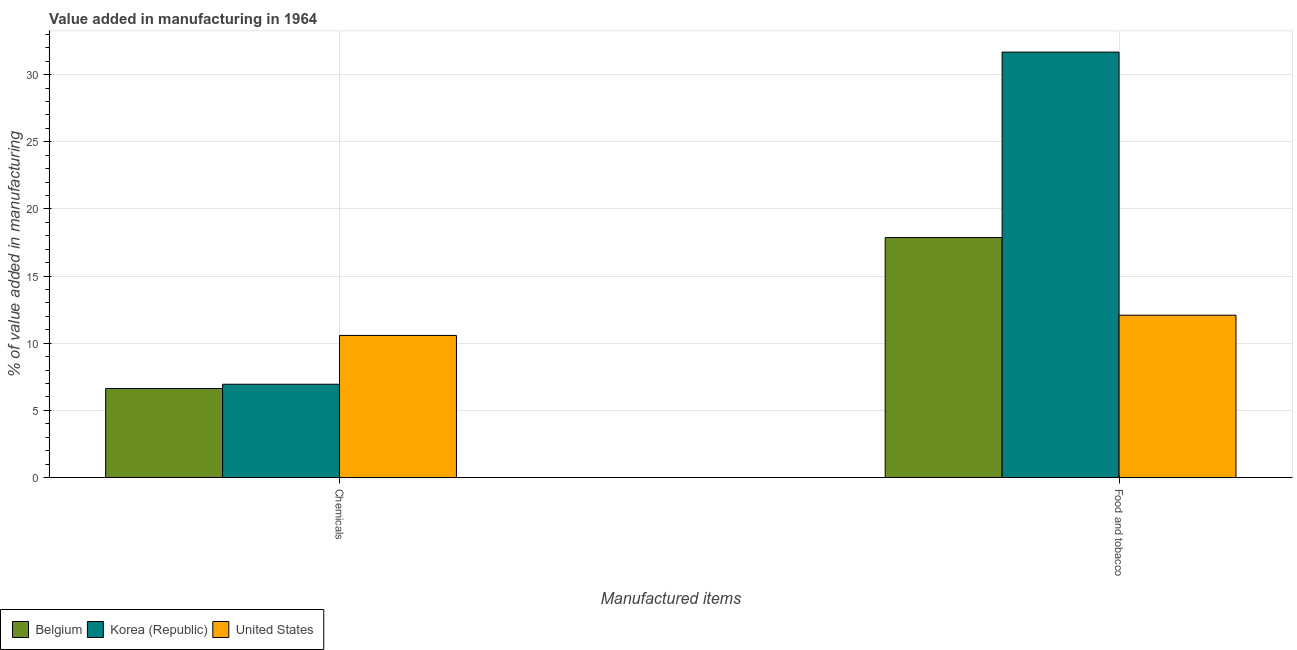How many different coloured bars are there?
Your answer should be compact. 3. Are the number of bars per tick equal to the number of legend labels?
Your answer should be very brief. Yes. How many bars are there on the 1st tick from the right?
Offer a very short reply. 3. What is the label of the 1st group of bars from the left?
Keep it short and to the point. Chemicals. What is the value added by  manufacturing chemicals in Korea (Republic)?
Your response must be concise. 6.95. Across all countries, what is the maximum value added by manufacturing food and tobacco?
Provide a short and direct response. 31.68. Across all countries, what is the minimum value added by  manufacturing chemicals?
Provide a succinct answer. 6.63. In which country was the value added by manufacturing food and tobacco maximum?
Your answer should be very brief. Korea (Republic). What is the total value added by  manufacturing chemicals in the graph?
Offer a very short reply. 24.16. What is the difference between the value added by manufacturing food and tobacco in Korea (Republic) and that in United States?
Your answer should be compact. 19.59. What is the difference between the value added by  manufacturing chemicals in Korea (Republic) and the value added by manufacturing food and tobacco in United States?
Keep it short and to the point. -5.14. What is the average value added by manufacturing food and tobacco per country?
Make the answer very short. 20.55. What is the difference between the value added by  manufacturing chemicals and value added by manufacturing food and tobacco in Korea (Republic)?
Keep it short and to the point. -24.73. In how many countries, is the value added by  manufacturing chemicals greater than 32 %?
Your answer should be very brief. 0. What is the ratio of the value added by manufacturing food and tobacco in Korea (Republic) to that in Belgium?
Make the answer very short. 1.77. Is the value added by manufacturing food and tobacco in United States less than that in Korea (Republic)?
Your response must be concise. Yes. In how many countries, is the value added by manufacturing food and tobacco greater than the average value added by manufacturing food and tobacco taken over all countries?
Make the answer very short. 1. What does the 2nd bar from the left in Food and tobacco represents?
Offer a very short reply. Korea (Republic). How many bars are there?
Provide a succinct answer. 6. Does the graph contain any zero values?
Your response must be concise. No. Does the graph contain grids?
Make the answer very short. Yes. Where does the legend appear in the graph?
Your answer should be compact. Bottom left. How are the legend labels stacked?
Your response must be concise. Horizontal. What is the title of the graph?
Keep it short and to the point. Value added in manufacturing in 1964. Does "Egypt, Arab Rep." appear as one of the legend labels in the graph?
Your answer should be compact. No. What is the label or title of the X-axis?
Your answer should be very brief. Manufactured items. What is the label or title of the Y-axis?
Offer a very short reply. % of value added in manufacturing. What is the % of value added in manufacturing in Belgium in Chemicals?
Your answer should be very brief. 6.63. What is the % of value added in manufacturing of Korea (Republic) in Chemicals?
Provide a short and direct response. 6.95. What is the % of value added in manufacturing in United States in Chemicals?
Ensure brevity in your answer.  10.58. What is the % of value added in manufacturing in Belgium in Food and tobacco?
Your response must be concise. 17.87. What is the % of value added in manufacturing of Korea (Republic) in Food and tobacco?
Make the answer very short. 31.68. What is the % of value added in manufacturing in United States in Food and tobacco?
Make the answer very short. 12.09. Across all Manufactured items, what is the maximum % of value added in manufacturing in Belgium?
Your answer should be compact. 17.87. Across all Manufactured items, what is the maximum % of value added in manufacturing of Korea (Republic)?
Make the answer very short. 31.68. Across all Manufactured items, what is the maximum % of value added in manufacturing in United States?
Keep it short and to the point. 12.09. Across all Manufactured items, what is the minimum % of value added in manufacturing of Belgium?
Ensure brevity in your answer.  6.63. Across all Manufactured items, what is the minimum % of value added in manufacturing in Korea (Republic)?
Offer a very short reply. 6.95. Across all Manufactured items, what is the minimum % of value added in manufacturing of United States?
Keep it short and to the point. 10.58. What is the total % of value added in manufacturing in Belgium in the graph?
Provide a succinct answer. 24.5. What is the total % of value added in manufacturing in Korea (Republic) in the graph?
Your answer should be compact. 38.63. What is the total % of value added in manufacturing of United States in the graph?
Make the answer very short. 22.67. What is the difference between the % of value added in manufacturing of Belgium in Chemicals and that in Food and tobacco?
Your answer should be very brief. -11.24. What is the difference between the % of value added in manufacturing of Korea (Republic) in Chemicals and that in Food and tobacco?
Ensure brevity in your answer.  -24.73. What is the difference between the % of value added in manufacturing in United States in Chemicals and that in Food and tobacco?
Your answer should be compact. -1.5. What is the difference between the % of value added in manufacturing of Belgium in Chemicals and the % of value added in manufacturing of Korea (Republic) in Food and tobacco?
Give a very brief answer. -25.05. What is the difference between the % of value added in manufacturing of Belgium in Chemicals and the % of value added in manufacturing of United States in Food and tobacco?
Provide a succinct answer. -5.46. What is the difference between the % of value added in manufacturing in Korea (Republic) in Chemicals and the % of value added in manufacturing in United States in Food and tobacco?
Make the answer very short. -5.14. What is the average % of value added in manufacturing in Belgium per Manufactured items?
Your answer should be very brief. 12.25. What is the average % of value added in manufacturing in Korea (Republic) per Manufactured items?
Keep it short and to the point. 19.31. What is the average % of value added in manufacturing in United States per Manufactured items?
Give a very brief answer. 11.34. What is the difference between the % of value added in manufacturing in Belgium and % of value added in manufacturing in Korea (Republic) in Chemicals?
Give a very brief answer. -0.32. What is the difference between the % of value added in manufacturing in Belgium and % of value added in manufacturing in United States in Chemicals?
Your response must be concise. -3.95. What is the difference between the % of value added in manufacturing of Korea (Republic) and % of value added in manufacturing of United States in Chemicals?
Give a very brief answer. -3.64. What is the difference between the % of value added in manufacturing of Belgium and % of value added in manufacturing of Korea (Republic) in Food and tobacco?
Keep it short and to the point. -13.81. What is the difference between the % of value added in manufacturing of Belgium and % of value added in manufacturing of United States in Food and tobacco?
Ensure brevity in your answer.  5.78. What is the difference between the % of value added in manufacturing of Korea (Republic) and % of value added in manufacturing of United States in Food and tobacco?
Your response must be concise. 19.59. What is the ratio of the % of value added in manufacturing of Belgium in Chemicals to that in Food and tobacco?
Give a very brief answer. 0.37. What is the ratio of the % of value added in manufacturing in Korea (Republic) in Chemicals to that in Food and tobacco?
Give a very brief answer. 0.22. What is the ratio of the % of value added in manufacturing in United States in Chemicals to that in Food and tobacco?
Keep it short and to the point. 0.88. What is the difference between the highest and the second highest % of value added in manufacturing in Belgium?
Give a very brief answer. 11.24. What is the difference between the highest and the second highest % of value added in manufacturing of Korea (Republic)?
Provide a short and direct response. 24.73. What is the difference between the highest and the second highest % of value added in manufacturing in United States?
Make the answer very short. 1.5. What is the difference between the highest and the lowest % of value added in manufacturing of Belgium?
Offer a very short reply. 11.24. What is the difference between the highest and the lowest % of value added in manufacturing of Korea (Republic)?
Your answer should be very brief. 24.73. What is the difference between the highest and the lowest % of value added in manufacturing of United States?
Offer a terse response. 1.5. 